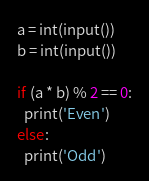<code> <loc_0><loc_0><loc_500><loc_500><_Python_>a = int(input())
b = int(input())

if (a * b) % 2 == 0:
  print('Even')
else:
  print('Odd')</code> 